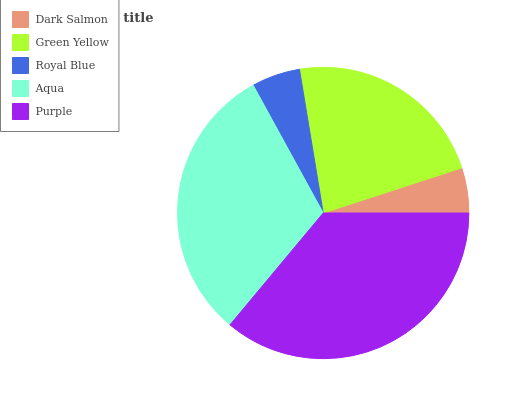Is Dark Salmon the minimum?
Answer yes or no. Yes. Is Purple the maximum?
Answer yes or no. Yes. Is Green Yellow the minimum?
Answer yes or no. No. Is Green Yellow the maximum?
Answer yes or no. No. Is Green Yellow greater than Dark Salmon?
Answer yes or no. Yes. Is Dark Salmon less than Green Yellow?
Answer yes or no. Yes. Is Dark Salmon greater than Green Yellow?
Answer yes or no. No. Is Green Yellow less than Dark Salmon?
Answer yes or no. No. Is Green Yellow the high median?
Answer yes or no. Yes. Is Green Yellow the low median?
Answer yes or no. Yes. Is Aqua the high median?
Answer yes or no. No. Is Purple the low median?
Answer yes or no. No. 